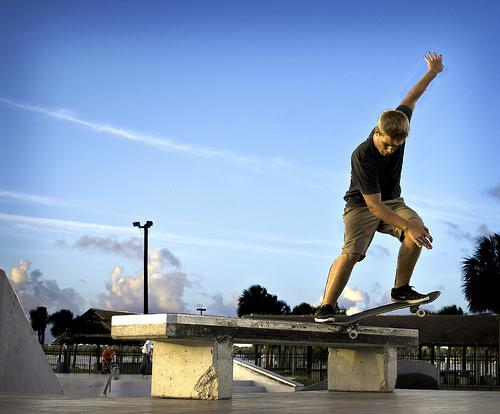Question: how many people in red shirts?
Choices:
A. 12.
B. 13.
C. 5.
D. One person.
Answer with the letter. Answer: D Question: how many steps?
Choices:
A. Four steps.
B. Two steps.
C. Six steps.
D. Eight steps.
Answer with the letter. Answer: B Question: what color shorts is the boy wearing?
Choices:
A. Teal.
B. Purple.
C. Neon.
D. Tan.
Answer with the letter. Answer: D Question: who has on a black shirt?
Choices:
A. The boy.
B. The man.
C. The teenager.
D. The young woman.
Answer with the letter. Answer: A Question: what is the bench made of?
Choices:
A. Wood.
B. Metal.
C. Plastic.
D. Stone.
Answer with the letter. Answer: D 